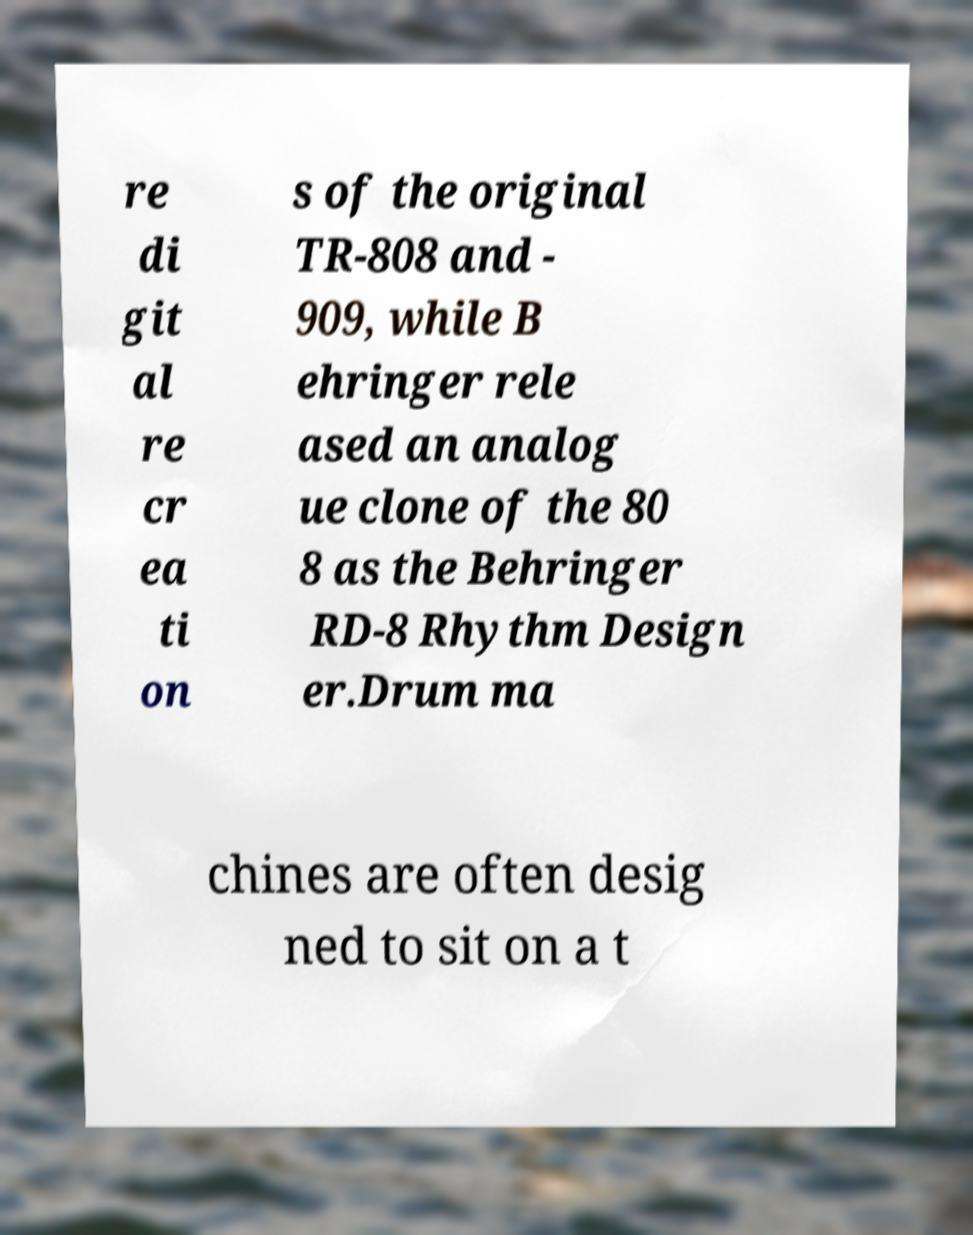Can you read and provide the text displayed in the image?This photo seems to have some interesting text. Can you extract and type it out for me? re di git al re cr ea ti on s of the original TR-808 and - 909, while B ehringer rele ased an analog ue clone of the 80 8 as the Behringer RD-8 Rhythm Design er.Drum ma chines are often desig ned to sit on a t 